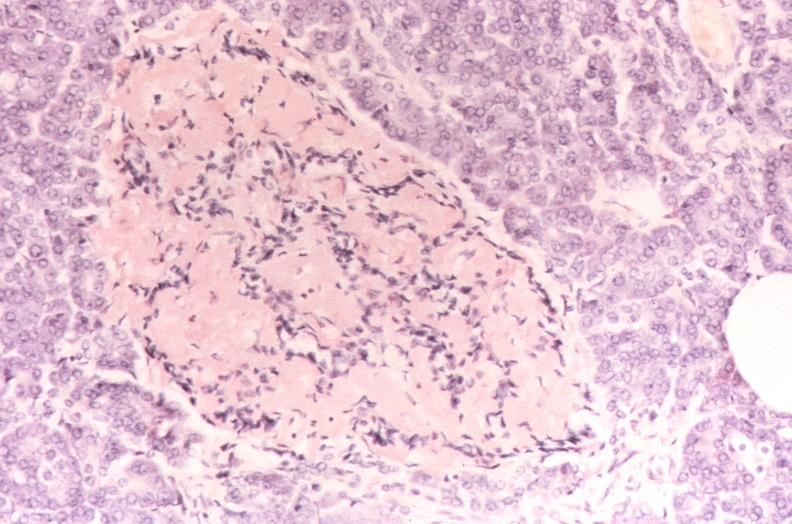does edema show pancreatic islet, amyloidosis diabetes mellitus, congo red stain?
Answer the question using a single word or phrase. No 